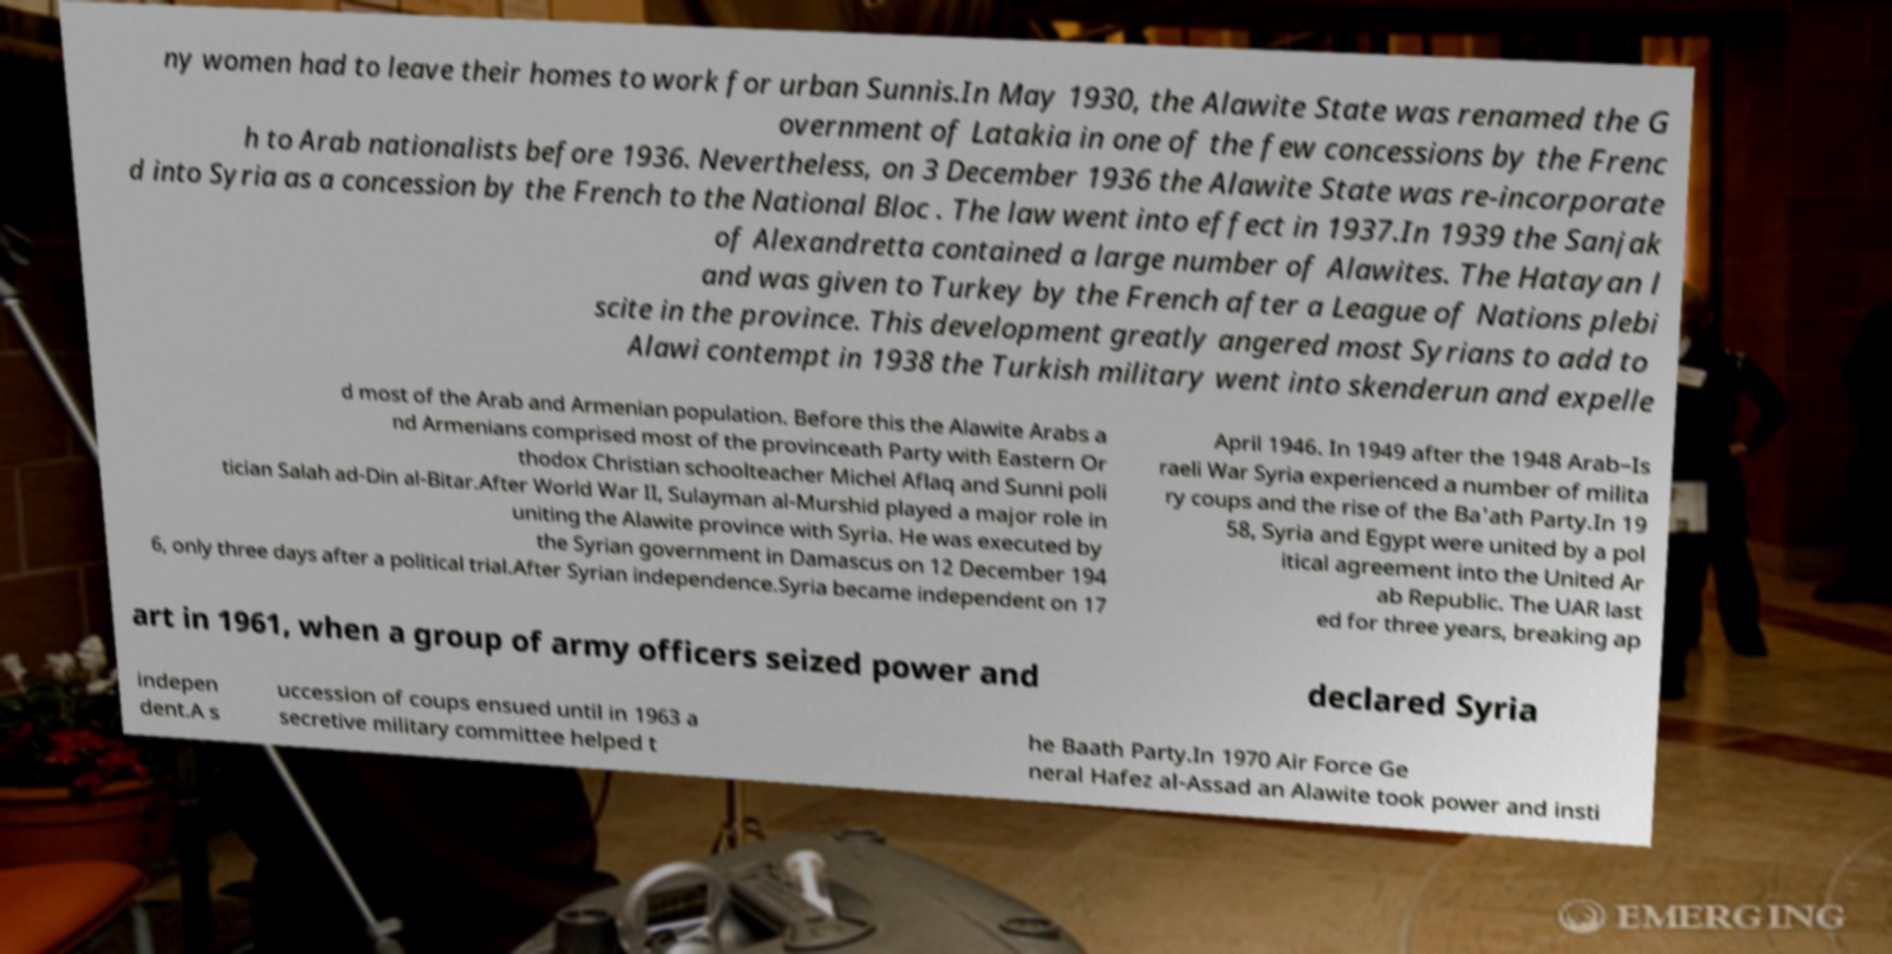Can you accurately transcribe the text from the provided image for me? ny women had to leave their homes to work for urban Sunnis.In May 1930, the Alawite State was renamed the G overnment of Latakia in one of the few concessions by the Frenc h to Arab nationalists before 1936. Nevertheless, on 3 December 1936 the Alawite State was re-incorporate d into Syria as a concession by the French to the National Bloc . The law went into effect in 1937.In 1939 the Sanjak of Alexandretta contained a large number of Alawites. The Hatayan l and was given to Turkey by the French after a League of Nations plebi scite in the province. This development greatly angered most Syrians to add to Alawi contempt in 1938 the Turkish military went into skenderun and expelle d most of the Arab and Armenian population. Before this the Alawite Arabs a nd Armenians comprised most of the provinceath Party with Eastern Or thodox Christian schoolteacher Michel Aflaq and Sunni poli tician Salah ad-Din al-Bitar.After World War II, Sulayman al-Murshid played a major role in uniting the Alawite province with Syria. He was executed by the Syrian government in Damascus on 12 December 194 6, only three days after a political trial.After Syrian independence.Syria became independent on 17 April 1946. In 1949 after the 1948 Arab–Is raeli War Syria experienced a number of milita ry coups and the rise of the Ba'ath Party.In 19 58, Syria and Egypt were united by a pol itical agreement into the United Ar ab Republic. The UAR last ed for three years, breaking ap art in 1961, when a group of army officers seized power and declared Syria indepen dent.A s uccession of coups ensued until in 1963 a secretive military committee helped t he Baath Party.In 1970 Air Force Ge neral Hafez al-Assad an Alawite took power and insti 